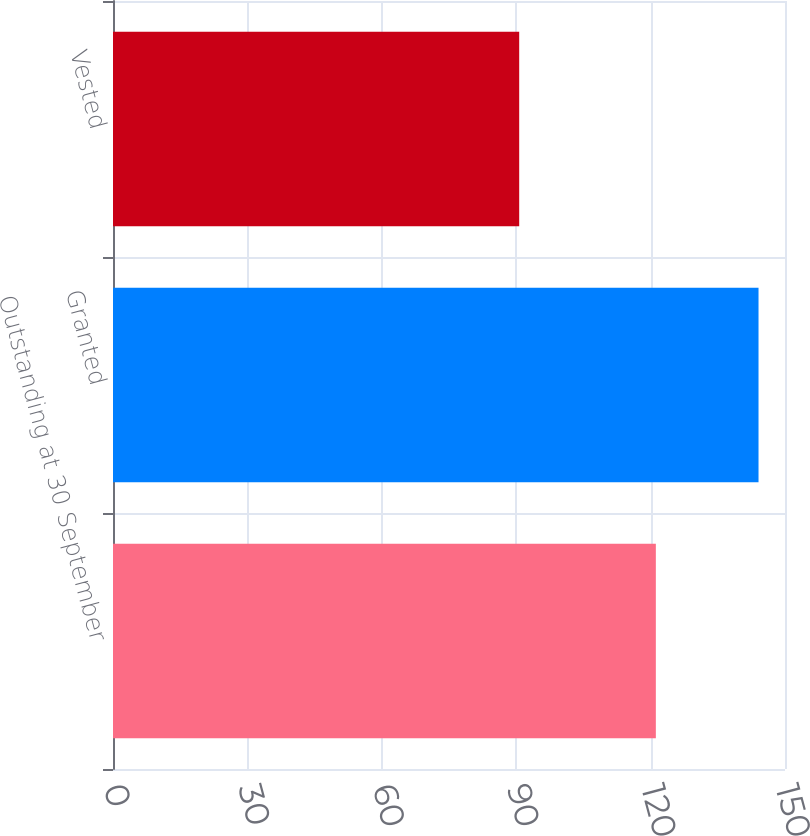Convert chart to OTSL. <chart><loc_0><loc_0><loc_500><loc_500><bar_chart><fcel>Outstanding at 30 September<fcel>Granted<fcel>Vested<nl><fcel>121.17<fcel>144.09<fcel>90.67<nl></chart> 